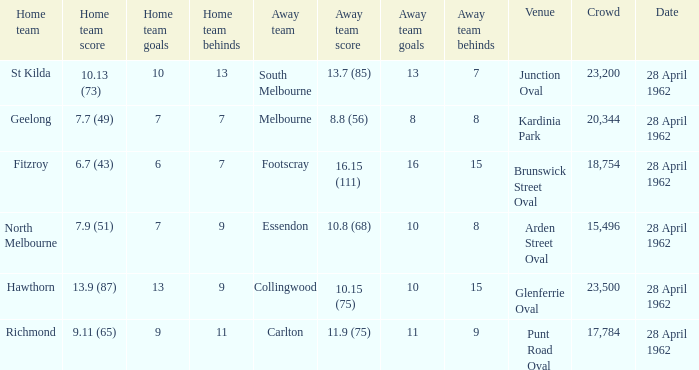What was the crowd size when there was a home team score of 10.13 (73)? 23200.0. 